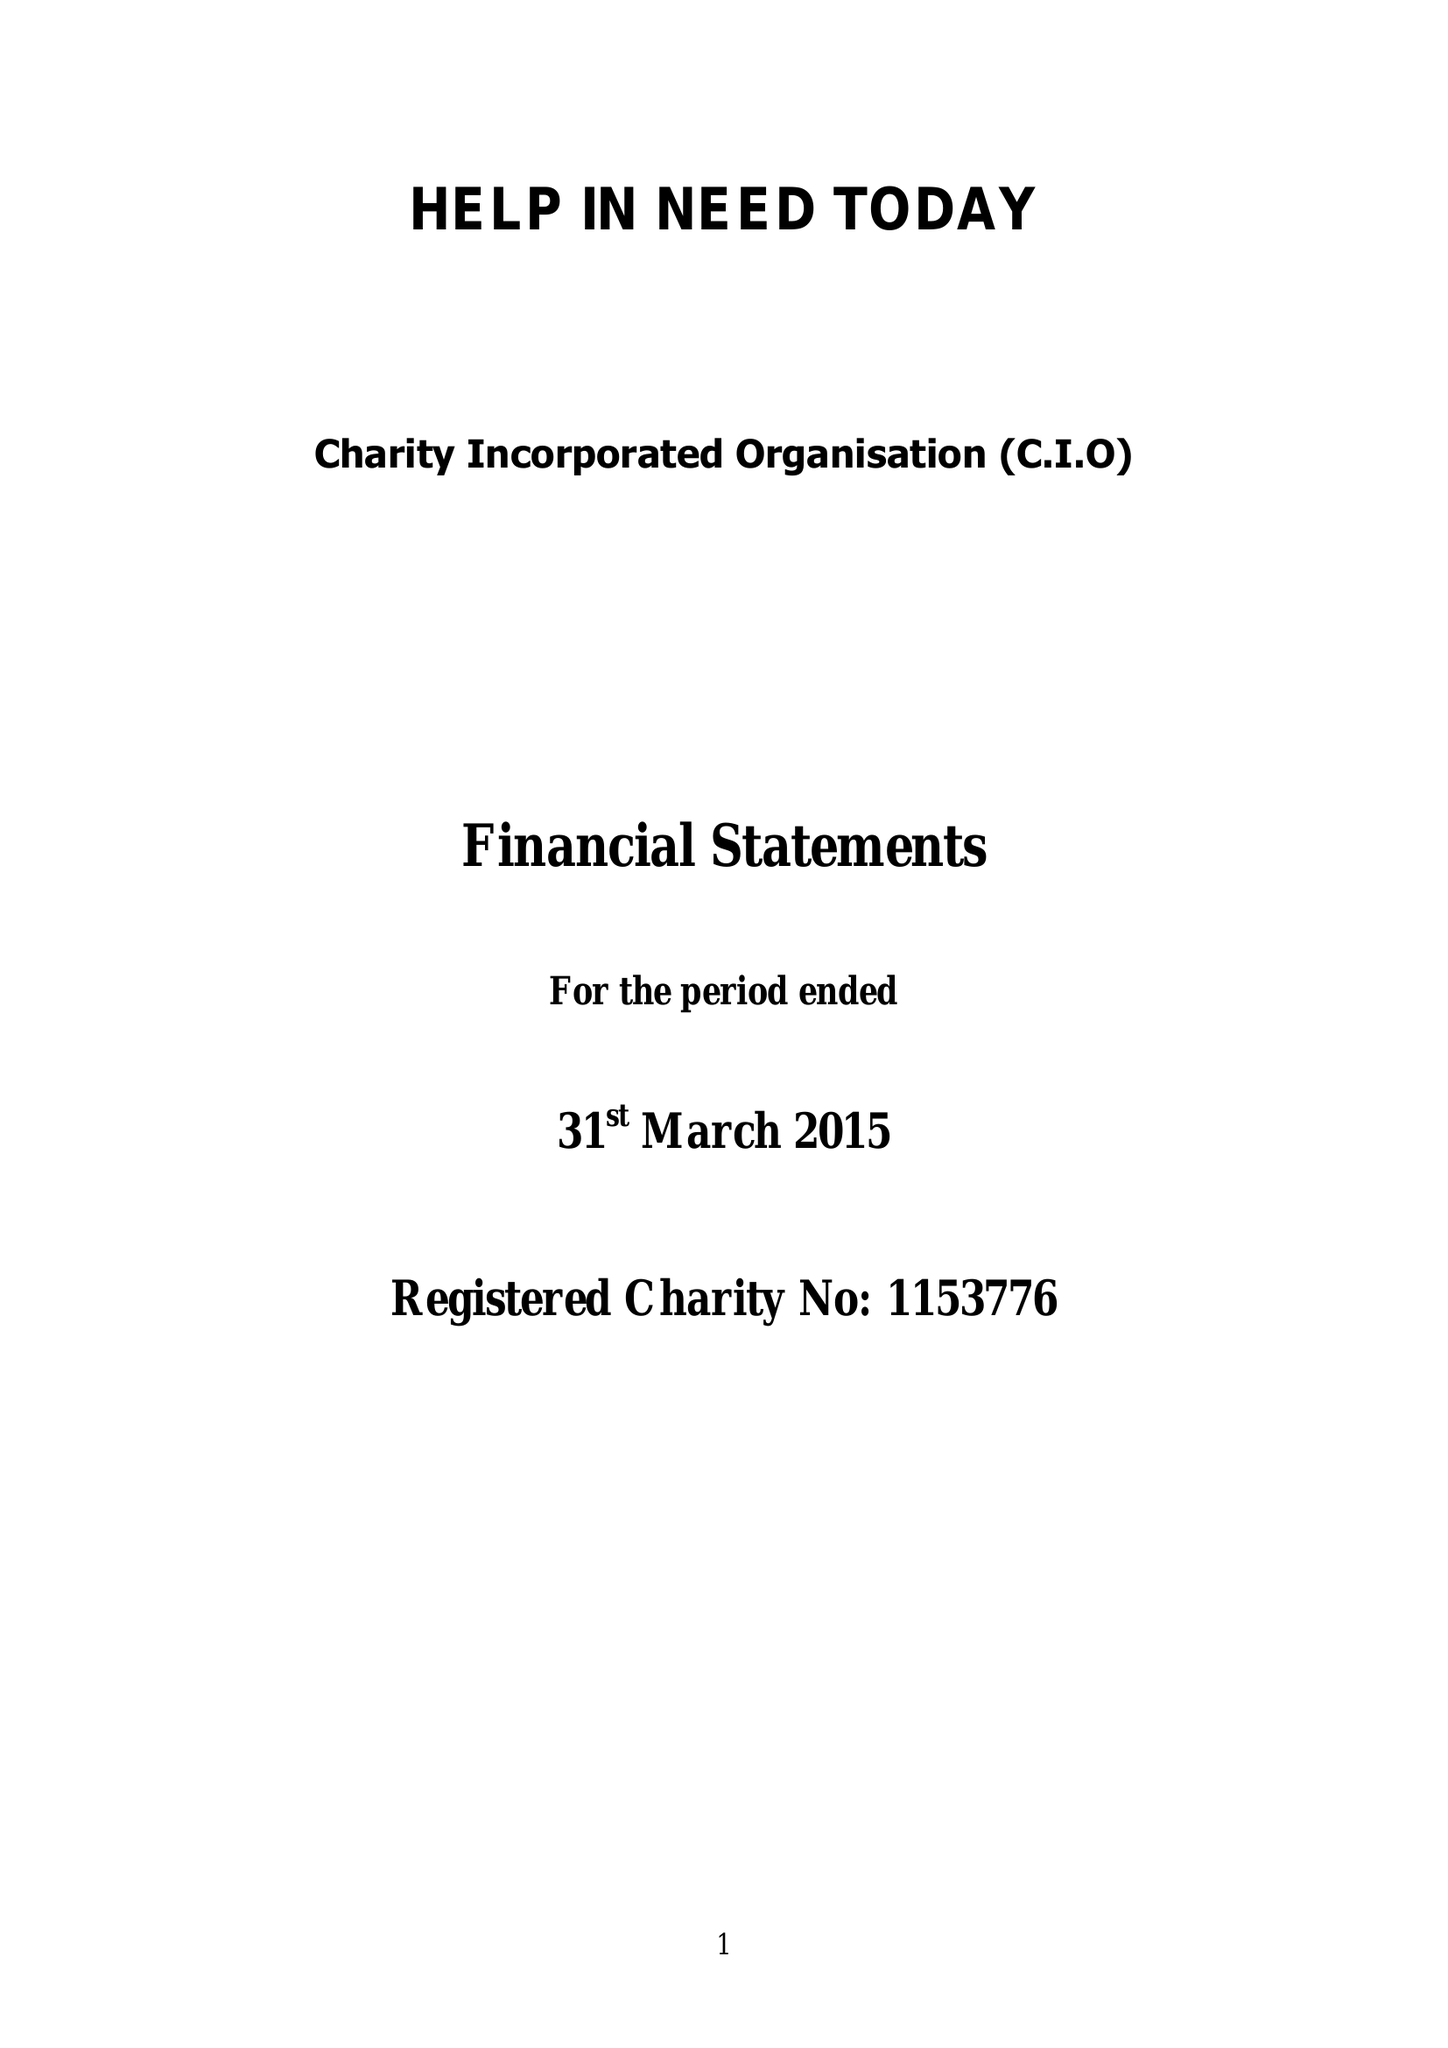What is the value for the spending_annually_in_british_pounds?
Answer the question using a single word or phrase. None 